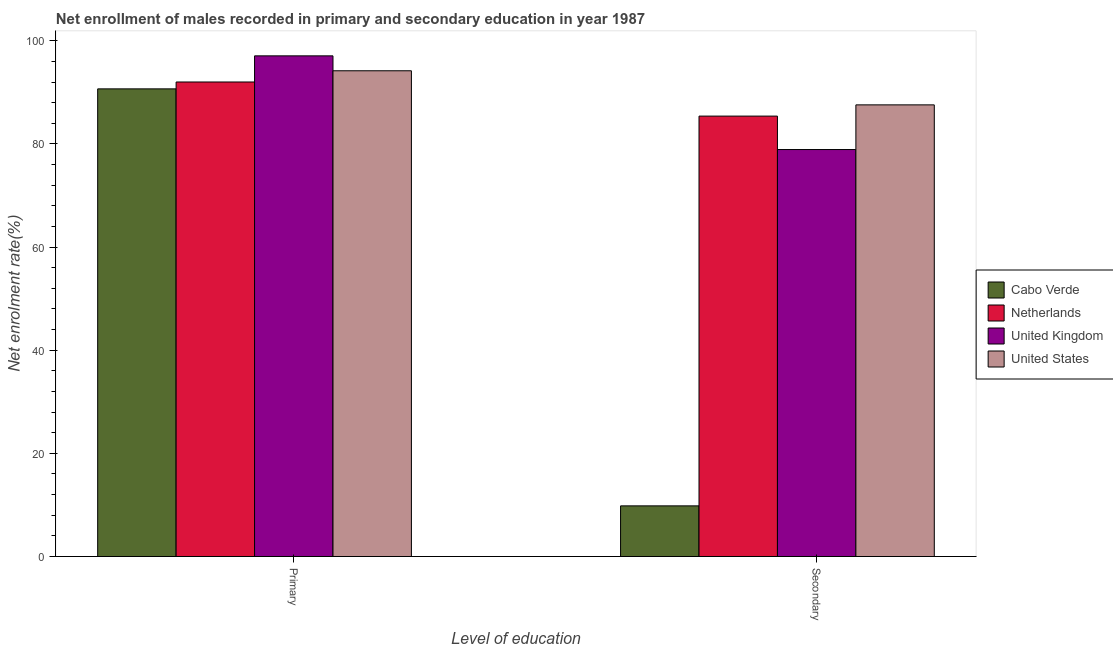How many groups of bars are there?
Give a very brief answer. 2. Are the number of bars per tick equal to the number of legend labels?
Offer a terse response. Yes. How many bars are there on the 2nd tick from the right?
Provide a short and direct response. 4. What is the label of the 2nd group of bars from the left?
Provide a succinct answer. Secondary. What is the enrollment rate in secondary education in Cabo Verde?
Make the answer very short. 9.82. Across all countries, what is the maximum enrollment rate in secondary education?
Offer a terse response. 87.57. Across all countries, what is the minimum enrollment rate in secondary education?
Your response must be concise. 9.82. In which country was the enrollment rate in primary education maximum?
Provide a succinct answer. United Kingdom. In which country was the enrollment rate in primary education minimum?
Offer a terse response. Cabo Verde. What is the total enrollment rate in secondary education in the graph?
Provide a short and direct response. 261.69. What is the difference between the enrollment rate in secondary education in Cabo Verde and that in United States?
Offer a very short reply. -77.75. What is the difference between the enrollment rate in primary education in United States and the enrollment rate in secondary education in Cabo Verde?
Provide a short and direct response. 84.36. What is the average enrollment rate in secondary education per country?
Your answer should be very brief. 65.42. What is the difference between the enrollment rate in secondary education and enrollment rate in primary education in Netherlands?
Keep it short and to the point. -6.62. What is the ratio of the enrollment rate in secondary education in United States to that in United Kingdom?
Your response must be concise. 1.11. Is the enrollment rate in primary education in United States less than that in Cabo Verde?
Offer a terse response. No. In how many countries, is the enrollment rate in primary education greater than the average enrollment rate in primary education taken over all countries?
Provide a short and direct response. 2. What does the 1st bar from the left in Secondary represents?
Your answer should be very brief. Cabo Verde. Does the graph contain any zero values?
Keep it short and to the point. No. How are the legend labels stacked?
Ensure brevity in your answer.  Vertical. What is the title of the graph?
Give a very brief answer. Net enrollment of males recorded in primary and secondary education in year 1987. Does "Lesotho" appear as one of the legend labels in the graph?
Your answer should be compact. No. What is the label or title of the X-axis?
Give a very brief answer. Level of education. What is the label or title of the Y-axis?
Make the answer very short. Net enrolment rate(%). What is the Net enrolment rate(%) in Cabo Verde in Primary?
Ensure brevity in your answer.  90.67. What is the Net enrolment rate(%) in Netherlands in Primary?
Provide a short and direct response. 92. What is the Net enrolment rate(%) of United Kingdom in Primary?
Offer a terse response. 97.07. What is the Net enrolment rate(%) in United States in Primary?
Offer a terse response. 94.18. What is the Net enrolment rate(%) in Cabo Verde in Secondary?
Give a very brief answer. 9.82. What is the Net enrolment rate(%) in Netherlands in Secondary?
Keep it short and to the point. 85.39. What is the Net enrolment rate(%) in United Kingdom in Secondary?
Your response must be concise. 78.91. What is the Net enrolment rate(%) in United States in Secondary?
Offer a terse response. 87.57. Across all Level of education, what is the maximum Net enrolment rate(%) of Cabo Verde?
Offer a terse response. 90.67. Across all Level of education, what is the maximum Net enrolment rate(%) of Netherlands?
Keep it short and to the point. 92. Across all Level of education, what is the maximum Net enrolment rate(%) in United Kingdom?
Offer a very short reply. 97.07. Across all Level of education, what is the maximum Net enrolment rate(%) in United States?
Your answer should be very brief. 94.18. Across all Level of education, what is the minimum Net enrolment rate(%) in Cabo Verde?
Ensure brevity in your answer.  9.82. Across all Level of education, what is the minimum Net enrolment rate(%) of Netherlands?
Your answer should be very brief. 85.39. Across all Level of education, what is the minimum Net enrolment rate(%) in United Kingdom?
Offer a very short reply. 78.91. Across all Level of education, what is the minimum Net enrolment rate(%) in United States?
Make the answer very short. 87.57. What is the total Net enrolment rate(%) in Cabo Verde in the graph?
Give a very brief answer. 100.49. What is the total Net enrolment rate(%) in Netherlands in the graph?
Keep it short and to the point. 177.39. What is the total Net enrolment rate(%) of United Kingdom in the graph?
Your response must be concise. 175.98. What is the total Net enrolment rate(%) in United States in the graph?
Provide a succinct answer. 181.75. What is the difference between the Net enrolment rate(%) of Cabo Verde in Primary and that in Secondary?
Ensure brevity in your answer.  80.85. What is the difference between the Net enrolment rate(%) in Netherlands in Primary and that in Secondary?
Give a very brief answer. 6.62. What is the difference between the Net enrolment rate(%) of United Kingdom in Primary and that in Secondary?
Make the answer very short. 18.16. What is the difference between the Net enrolment rate(%) in United States in Primary and that in Secondary?
Ensure brevity in your answer.  6.61. What is the difference between the Net enrolment rate(%) of Cabo Verde in Primary and the Net enrolment rate(%) of Netherlands in Secondary?
Give a very brief answer. 5.28. What is the difference between the Net enrolment rate(%) in Cabo Verde in Primary and the Net enrolment rate(%) in United Kingdom in Secondary?
Your answer should be very brief. 11.76. What is the difference between the Net enrolment rate(%) in Cabo Verde in Primary and the Net enrolment rate(%) in United States in Secondary?
Offer a very short reply. 3.1. What is the difference between the Net enrolment rate(%) in Netherlands in Primary and the Net enrolment rate(%) in United Kingdom in Secondary?
Offer a terse response. 13.1. What is the difference between the Net enrolment rate(%) of Netherlands in Primary and the Net enrolment rate(%) of United States in Secondary?
Provide a succinct answer. 4.44. What is the difference between the Net enrolment rate(%) in United Kingdom in Primary and the Net enrolment rate(%) in United States in Secondary?
Offer a very short reply. 9.5. What is the average Net enrolment rate(%) in Cabo Verde per Level of education?
Your response must be concise. 50.25. What is the average Net enrolment rate(%) in Netherlands per Level of education?
Your answer should be compact. 88.7. What is the average Net enrolment rate(%) of United Kingdom per Level of education?
Offer a terse response. 87.99. What is the average Net enrolment rate(%) of United States per Level of education?
Your answer should be compact. 90.87. What is the difference between the Net enrolment rate(%) of Cabo Verde and Net enrolment rate(%) of Netherlands in Primary?
Provide a succinct answer. -1.33. What is the difference between the Net enrolment rate(%) in Cabo Verde and Net enrolment rate(%) in United Kingdom in Primary?
Make the answer very short. -6.4. What is the difference between the Net enrolment rate(%) in Cabo Verde and Net enrolment rate(%) in United States in Primary?
Your response must be concise. -3.51. What is the difference between the Net enrolment rate(%) of Netherlands and Net enrolment rate(%) of United Kingdom in Primary?
Keep it short and to the point. -5.07. What is the difference between the Net enrolment rate(%) in Netherlands and Net enrolment rate(%) in United States in Primary?
Provide a succinct answer. -2.17. What is the difference between the Net enrolment rate(%) of United Kingdom and Net enrolment rate(%) of United States in Primary?
Offer a terse response. 2.89. What is the difference between the Net enrolment rate(%) of Cabo Verde and Net enrolment rate(%) of Netherlands in Secondary?
Offer a very short reply. -75.57. What is the difference between the Net enrolment rate(%) of Cabo Verde and Net enrolment rate(%) of United Kingdom in Secondary?
Offer a very short reply. -69.08. What is the difference between the Net enrolment rate(%) in Cabo Verde and Net enrolment rate(%) in United States in Secondary?
Your answer should be compact. -77.75. What is the difference between the Net enrolment rate(%) of Netherlands and Net enrolment rate(%) of United Kingdom in Secondary?
Make the answer very short. 6.48. What is the difference between the Net enrolment rate(%) in Netherlands and Net enrolment rate(%) in United States in Secondary?
Provide a short and direct response. -2.18. What is the difference between the Net enrolment rate(%) of United Kingdom and Net enrolment rate(%) of United States in Secondary?
Offer a terse response. -8.66. What is the ratio of the Net enrolment rate(%) in Cabo Verde in Primary to that in Secondary?
Give a very brief answer. 9.23. What is the ratio of the Net enrolment rate(%) of Netherlands in Primary to that in Secondary?
Your response must be concise. 1.08. What is the ratio of the Net enrolment rate(%) in United Kingdom in Primary to that in Secondary?
Keep it short and to the point. 1.23. What is the ratio of the Net enrolment rate(%) of United States in Primary to that in Secondary?
Provide a short and direct response. 1.08. What is the difference between the highest and the second highest Net enrolment rate(%) of Cabo Verde?
Your response must be concise. 80.85. What is the difference between the highest and the second highest Net enrolment rate(%) of Netherlands?
Offer a terse response. 6.62. What is the difference between the highest and the second highest Net enrolment rate(%) in United Kingdom?
Offer a terse response. 18.16. What is the difference between the highest and the second highest Net enrolment rate(%) in United States?
Provide a short and direct response. 6.61. What is the difference between the highest and the lowest Net enrolment rate(%) in Cabo Verde?
Your answer should be very brief. 80.85. What is the difference between the highest and the lowest Net enrolment rate(%) of Netherlands?
Provide a short and direct response. 6.62. What is the difference between the highest and the lowest Net enrolment rate(%) of United Kingdom?
Your response must be concise. 18.16. What is the difference between the highest and the lowest Net enrolment rate(%) in United States?
Your answer should be compact. 6.61. 